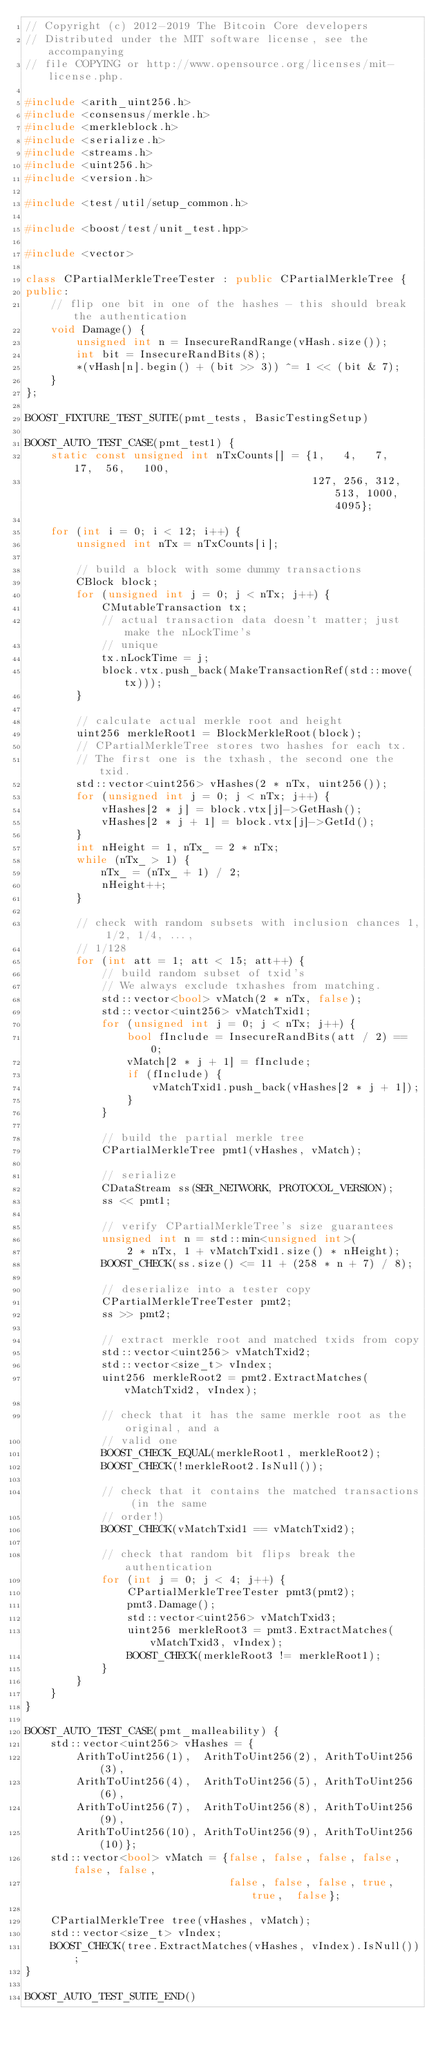<code> <loc_0><loc_0><loc_500><loc_500><_C++_>// Copyright (c) 2012-2019 The Bitcoin Core developers
// Distributed under the MIT software license, see the accompanying
// file COPYING or http://www.opensource.org/licenses/mit-license.php.

#include <arith_uint256.h>
#include <consensus/merkle.h>
#include <merkleblock.h>
#include <serialize.h>
#include <streams.h>
#include <uint256.h>
#include <version.h>

#include <test/util/setup_common.h>

#include <boost/test/unit_test.hpp>

#include <vector>

class CPartialMerkleTreeTester : public CPartialMerkleTree {
public:
    // flip one bit in one of the hashes - this should break the authentication
    void Damage() {
        unsigned int n = InsecureRandRange(vHash.size());
        int bit = InsecureRandBits(8);
        *(vHash[n].begin() + (bit >> 3)) ^= 1 << (bit & 7);
    }
};

BOOST_FIXTURE_TEST_SUITE(pmt_tests, BasicTestingSetup)

BOOST_AUTO_TEST_CASE(pmt_test1) {
    static const unsigned int nTxCounts[] = {1,   4,   7,   17,  56,   100,
                                             127, 256, 312, 513, 1000, 4095};

    for (int i = 0; i < 12; i++) {
        unsigned int nTx = nTxCounts[i];

        // build a block with some dummy transactions
        CBlock block;
        for (unsigned int j = 0; j < nTx; j++) {
            CMutableTransaction tx;
            // actual transaction data doesn't matter; just make the nLockTime's
            // unique
            tx.nLockTime = j;
            block.vtx.push_back(MakeTransactionRef(std::move(tx)));
        }

        // calculate actual merkle root and height
        uint256 merkleRoot1 = BlockMerkleRoot(block);
        // CPartialMerkleTree stores two hashes for each tx.
        // The first one is the txhash, the second one the txid.
        std::vector<uint256> vHashes(2 * nTx, uint256());
        for (unsigned int j = 0; j < nTx; j++) {
            vHashes[2 * j] = block.vtx[j]->GetHash();
            vHashes[2 * j + 1] = block.vtx[j]->GetId();
        }
        int nHeight = 1, nTx_ = 2 * nTx;
        while (nTx_ > 1) {
            nTx_ = (nTx_ + 1) / 2;
            nHeight++;
        }

        // check with random subsets with inclusion chances 1, 1/2, 1/4, ...,
        // 1/128
        for (int att = 1; att < 15; att++) {
            // build random subset of txid's
            // We always exclude txhashes from matching.
            std::vector<bool> vMatch(2 * nTx, false);
            std::vector<uint256> vMatchTxid1;
            for (unsigned int j = 0; j < nTx; j++) {
                bool fInclude = InsecureRandBits(att / 2) == 0;
                vMatch[2 * j + 1] = fInclude;
                if (fInclude) {
                    vMatchTxid1.push_back(vHashes[2 * j + 1]);
                }
            }

            // build the partial merkle tree
            CPartialMerkleTree pmt1(vHashes, vMatch);

            // serialize
            CDataStream ss(SER_NETWORK, PROTOCOL_VERSION);
            ss << pmt1;

            // verify CPartialMerkleTree's size guarantees
            unsigned int n = std::min<unsigned int>(
                2 * nTx, 1 + vMatchTxid1.size() * nHeight);
            BOOST_CHECK(ss.size() <= 11 + (258 * n + 7) / 8);

            // deserialize into a tester copy
            CPartialMerkleTreeTester pmt2;
            ss >> pmt2;

            // extract merkle root and matched txids from copy
            std::vector<uint256> vMatchTxid2;
            std::vector<size_t> vIndex;
            uint256 merkleRoot2 = pmt2.ExtractMatches(vMatchTxid2, vIndex);

            // check that it has the same merkle root as the original, and a
            // valid one
            BOOST_CHECK_EQUAL(merkleRoot1, merkleRoot2);
            BOOST_CHECK(!merkleRoot2.IsNull());

            // check that it contains the matched transactions (in the same
            // order!)
            BOOST_CHECK(vMatchTxid1 == vMatchTxid2);

            // check that random bit flips break the authentication
            for (int j = 0; j < 4; j++) {
                CPartialMerkleTreeTester pmt3(pmt2);
                pmt3.Damage();
                std::vector<uint256> vMatchTxid3;
                uint256 merkleRoot3 = pmt3.ExtractMatches(vMatchTxid3, vIndex);
                BOOST_CHECK(merkleRoot3 != merkleRoot1);
            }
        }
    }
}

BOOST_AUTO_TEST_CASE(pmt_malleability) {
    std::vector<uint256> vHashes = {
        ArithToUint256(1),  ArithToUint256(2), ArithToUint256(3),
        ArithToUint256(4),  ArithToUint256(5), ArithToUint256(6),
        ArithToUint256(7),  ArithToUint256(8), ArithToUint256(9),
        ArithToUint256(10), ArithToUint256(9), ArithToUint256(10)};
    std::vector<bool> vMatch = {false, false, false, false, false, false,
                                false, false, false, true,  true,  false};

    CPartialMerkleTree tree(vHashes, vMatch);
    std::vector<size_t> vIndex;
    BOOST_CHECK(tree.ExtractMatches(vHashes, vIndex).IsNull());
}

BOOST_AUTO_TEST_SUITE_END()
</code> 